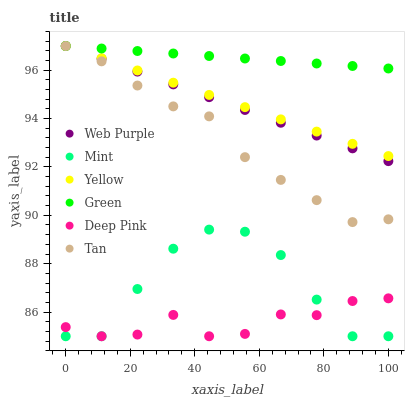Does Deep Pink have the minimum area under the curve?
Answer yes or no. Yes. Does Green have the maximum area under the curve?
Answer yes or no. Yes. Does Yellow have the minimum area under the curve?
Answer yes or no. No. Does Yellow have the maximum area under the curve?
Answer yes or no. No. Is Yellow the smoothest?
Answer yes or no. Yes. Is Mint the roughest?
Answer yes or no. Yes. Is Web Purple the smoothest?
Answer yes or no. No. Is Web Purple the roughest?
Answer yes or no. No. Does Deep Pink have the lowest value?
Answer yes or no. Yes. Does Yellow have the lowest value?
Answer yes or no. No. Does Tan have the highest value?
Answer yes or no. Yes. Does Mint have the highest value?
Answer yes or no. No. Is Deep Pink less than Web Purple?
Answer yes or no. Yes. Is Yellow greater than Mint?
Answer yes or no. Yes. Does Green intersect Tan?
Answer yes or no. Yes. Is Green less than Tan?
Answer yes or no. No. Is Green greater than Tan?
Answer yes or no. No. Does Deep Pink intersect Web Purple?
Answer yes or no. No. 